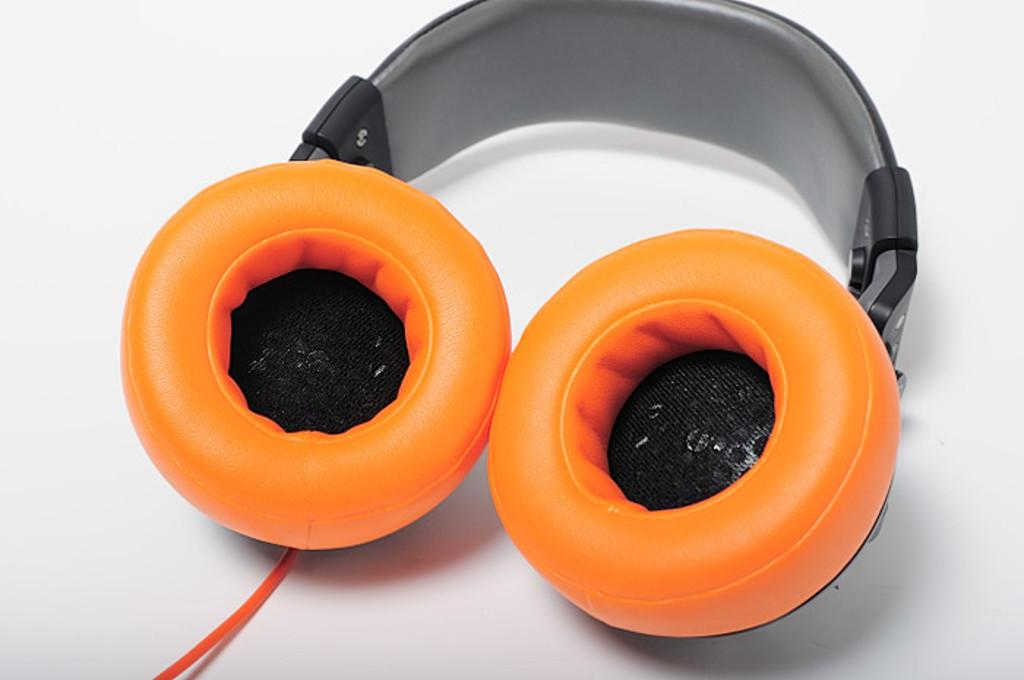What type of audio accessory is in the image? There is a headphone in the image. What colors are used for the headphone? The headphone is orange and black in color. Is there any connection between the headphone and another device? Yes, there is a wire associated with the headphone. What is the color of the surface on which the headphone and wire are placed? The headphone and wire are on a white surface. How much sugar is in the headphone in the image? There is no sugar present in the headphone or the image. 